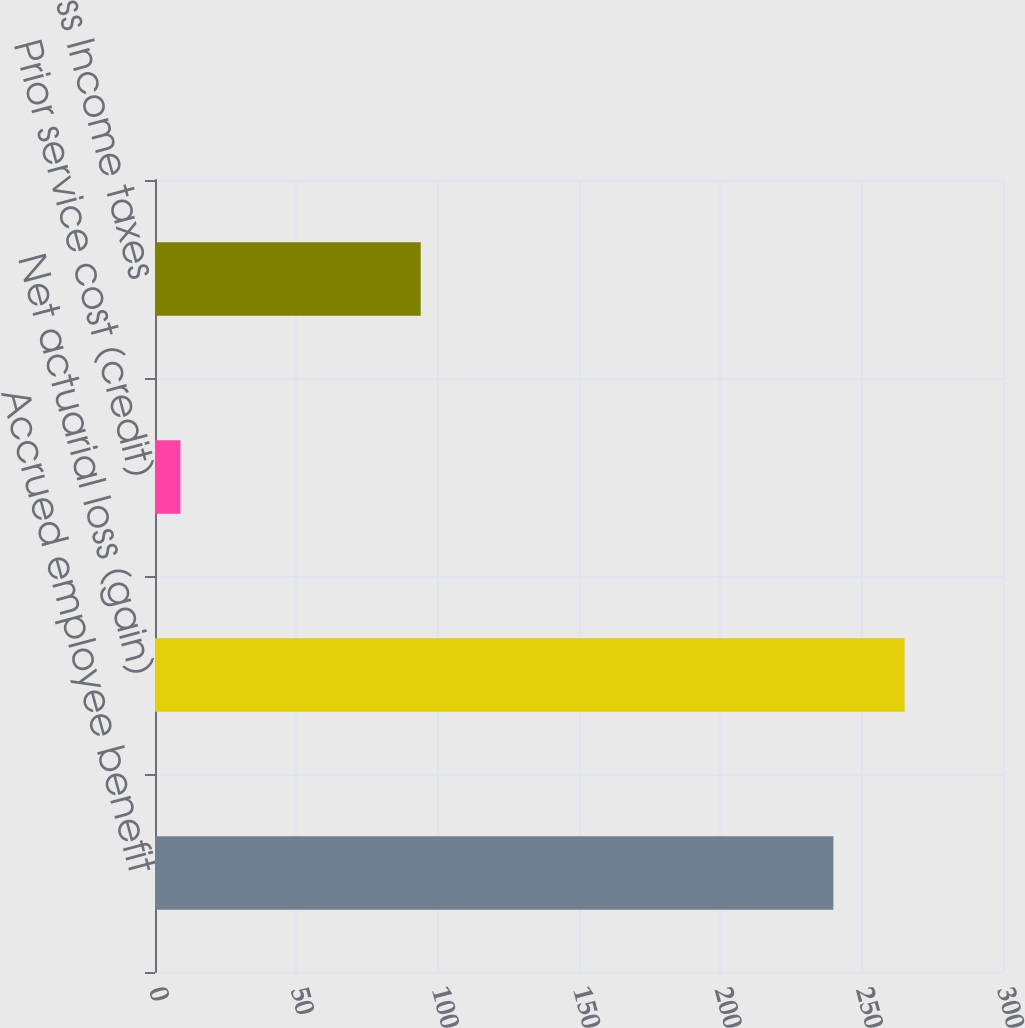Convert chart. <chart><loc_0><loc_0><loc_500><loc_500><bar_chart><fcel>Accrued employee benefit<fcel>Net actuarial loss (gain)<fcel>Prior service cost (credit)<fcel>Less Income taxes<nl><fcel>240<fcel>265.2<fcel>9<fcel>94<nl></chart> 